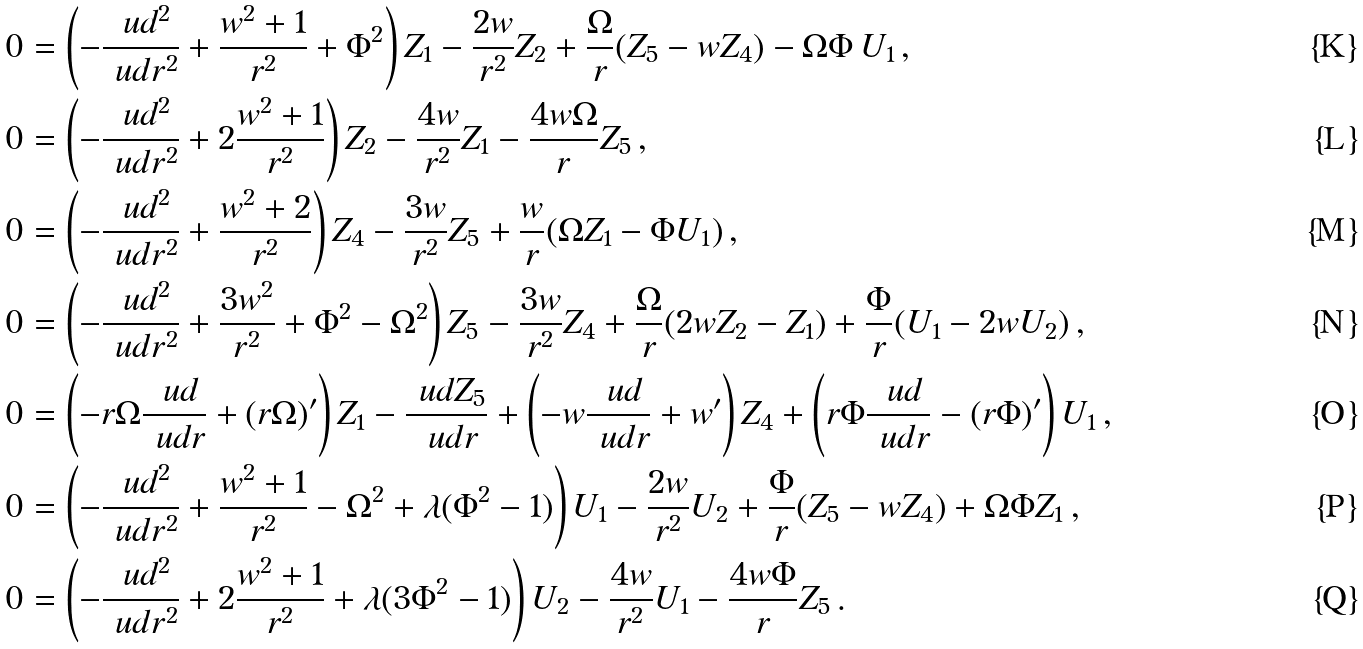Convert formula to latex. <formula><loc_0><loc_0><loc_500><loc_500>0 & = \left ( - \frac { \ u d ^ { 2 } } { \ u d r ^ { 2 } } + \frac { w ^ { 2 } + 1 } { r ^ { 2 } } + \Phi ^ { 2 } \right ) Z _ { 1 } - \frac { 2 w } { r ^ { 2 } } Z _ { 2 } + \frac { \Omega } { r } ( Z _ { 5 } - w Z _ { 4 } ) - \Omega \Phi \, U _ { 1 } \, , \\ 0 & = \left ( - \frac { \ u d ^ { 2 } } { \ u d r ^ { 2 } } + 2 \frac { w ^ { 2 } + 1 } { r ^ { 2 } } \right ) Z _ { 2 } - \frac { 4 w } { r ^ { 2 } } Z _ { 1 } - \frac { 4 w \Omega } { r } Z _ { 5 } \, , \\ 0 & = \left ( - \frac { \ u d ^ { 2 } } { \ u d r ^ { 2 } } + \frac { w ^ { 2 } + 2 } { r ^ { 2 } } \right ) Z _ { 4 } - \frac { 3 w } { r ^ { 2 } } Z _ { 5 } + \frac { w } { r } ( \Omega Z _ { 1 } - \Phi U _ { 1 } ) \, , \\ 0 & = \left ( - \frac { \ u d ^ { 2 } } { \ u d r ^ { 2 } } + \frac { 3 w ^ { 2 } } { r ^ { 2 } } + \Phi ^ { 2 } - \Omega ^ { 2 } \right ) Z _ { 5 } - \frac { 3 w } { r ^ { 2 } } Z _ { 4 } + \frac { \Omega } { r } ( 2 w Z _ { 2 } - Z _ { 1 } ) + \frac { \Phi } { r } ( U _ { 1 } - 2 w U _ { 2 } ) \, , \\ 0 & = \left ( - r \Omega \frac { \ u d } { \ u d r } + ( r \Omega ) ^ { \prime } \right ) Z _ { 1 } - \frac { \ u d Z _ { 5 } } { \ u d r } + \left ( - w \frac { \ u d } { \ u d r } + w ^ { \prime } \right ) Z _ { 4 } + \left ( r \Phi \frac { \ u d } { \ u d r } - ( r \Phi ) ^ { \prime } \right ) U _ { 1 } \, , \\ 0 & = \left ( - \frac { \ u d ^ { 2 } } { \ u d r ^ { 2 } } + \frac { w ^ { 2 } + 1 } { r ^ { 2 } } - \Omega ^ { 2 } + \lambda ( \Phi ^ { 2 } - 1 ) \right ) U _ { 1 } - \frac { 2 w } { r ^ { 2 } } U _ { 2 } + \frac { \Phi } { r } ( Z _ { 5 } - w Z _ { 4 } ) + \Omega \Phi Z _ { 1 } \, , \\ 0 & = \left ( - \frac { \ u d ^ { 2 } } { \ u d r ^ { 2 } } + 2 \frac { w ^ { 2 } + 1 } { r ^ { 2 } } + \lambda ( 3 \Phi ^ { 2 } - 1 ) \right ) U _ { 2 } - \frac { 4 w } { r ^ { 2 } } U _ { 1 } - \frac { 4 w \Phi } { r } Z _ { 5 } \, .</formula> 